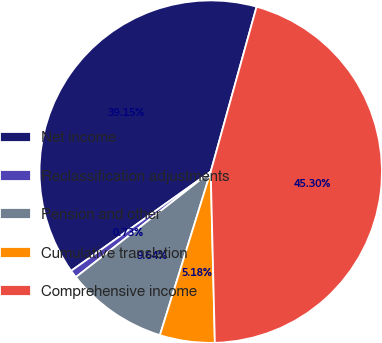Convert chart to OTSL. <chart><loc_0><loc_0><loc_500><loc_500><pie_chart><fcel>Net income<fcel>Reclassification adjustments<fcel>Pension and other<fcel>Cumulative translation<fcel>Comprehensive income<nl><fcel>39.15%<fcel>0.73%<fcel>9.64%<fcel>5.18%<fcel>45.3%<nl></chart> 